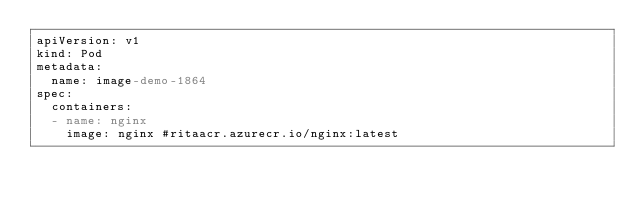Convert code to text. <code><loc_0><loc_0><loc_500><loc_500><_YAML_>apiVersion: v1
kind: Pod
metadata:
  name: image-demo-1864
spec:
  containers:
  - name: nginx
    image: nginx #ritaacr.azurecr.io/nginx:latest</code> 